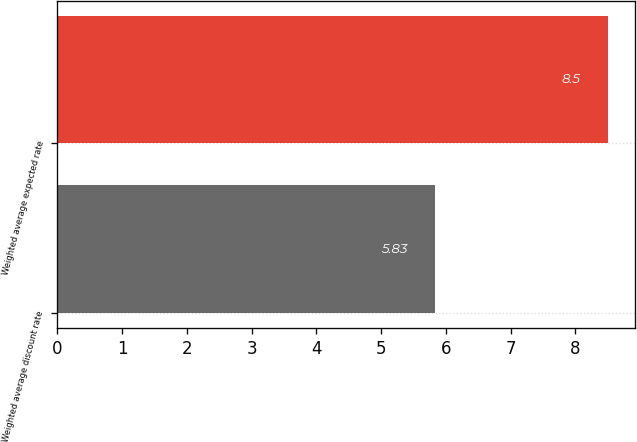Convert chart to OTSL. <chart><loc_0><loc_0><loc_500><loc_500><bar_chart><fcel>Weighted average discount rate<fcel>Weighted average expected rate<nl><fcel>5.83<fcel>8.5<nl></chart> 